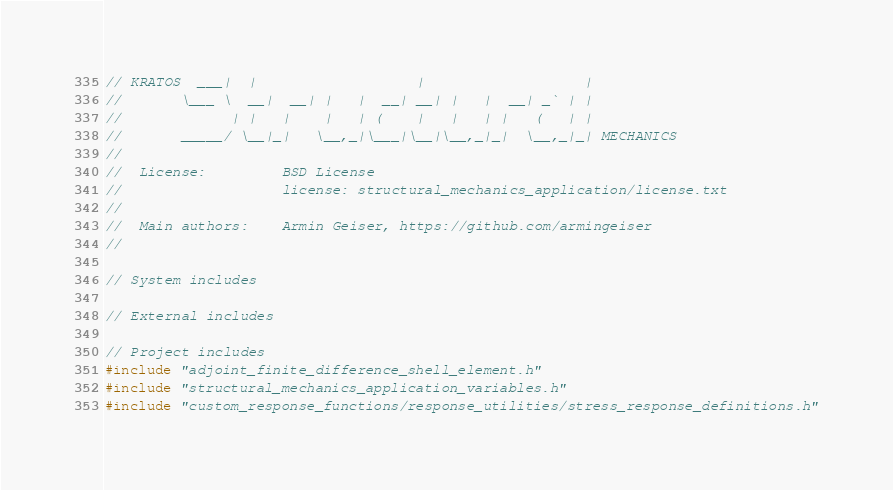<code> <loc_0><loc_0><loc_500><loc_500><_C++_>// KRATOS  ___|  |                   |                   |
//       \___ \  __|  __| |   |  __| __| |   |  __| _` | |
//             | |   |    |   | (    |   |   | |   (   | |
//       _____/ \__|_|   \__,_|\___|\__|\__,_|_|  \__,_|_| MECHANICS
//
//  License:		 BSD License
//					 license: structural_mechanics_application/license.txt
//
//  Main authors:    Armin Geiser, https://github.com/armingeiser
//

// System includes

// External includes

// Project includes
#include "adjoint_finite_difference_shell_element.h"
#include "structural_mechanics_application_variables.h"
#include "custom_response_functions/response_utilities/stress_response_definitions.h"</code> 